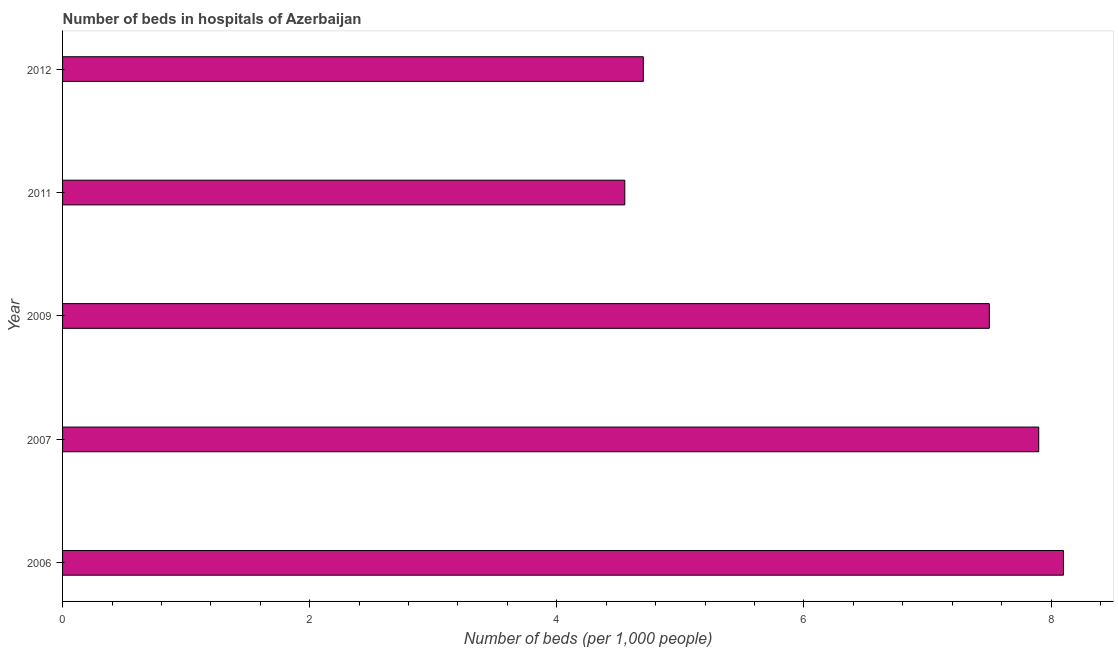Does the graph contain grids?
Give a very brief answer. No. What is the title of the graph?
Your answer should be very brief. Number of beds in hospitals of Azerbaijan. What is the label or title of the X-axis?
Provide a succinct answer. Number of beds (per 1,0 people). What is the label or title of the Y-axis?
Your answer should be compact. Year. What is the number of hospital beds in 2012?
Provide a short and direct response. 4.7. Across all years, what is the maximum number of hospital beds?
Your answer should be compact. 8.1. Across all years, what is the minimum number of hospital beds?
Keep it short and to the point. 4.55. In which year was the number of hospital beds maximum?
Make the answer very short. 2006. What is the sum of the number of hospital beds?
Keep it short and to the point. 32.75. What is the average number of hospital beds per year?
Ensure brevity in your answer.  6.55. What is the median number of hospital beds?
Provide a succinct answer. 7.5. In how many years, is the number of hospital beds greater than 3.6 %?
Ensure brevity in your answer.  5. What is the ratio of the number of hospital beds in 2007 to that in 2009?
Offer a very short reply. 1.05. Is the difference between the number of hospital beds in 2006 and 2009 greater than the difference between any two years?
Offer a very short reply. No. What is the difference between the highest and the second highest number of hospital beds?
Give a very brief answer. 0.2. What is the difference between the highest and the lowest number of hospital beds?
Make the answer very short. 3.55. In how many years, is the number of hospital beds greater than the average number of hospital beds taken over all years?
Ensure brevity in your answer.  3. Are all the bars in the graph horizontal?
Ensure brevity in your answer.  Yes. Are the values on the major ticks of X-axis written in scientific E-notation?
Keep it short and to the point. No. What is the Number of beds (per 1,000 people) of 2006?
Keep it short and to the point. 8.1. What is the Number of beds (per 1,000 people) of 2011?
Your response must be concise. 4.55. What is the difference between the Number of beds (per 1,000 people) in 2006 and 2011?
Give a very brief answer. 3.55. What is the difference between the Number of beds (per 1,000 people) in 2007 and 2011?
Your answer should be very brief. 3.35. What is the difference between the Number of beds (per 1,000 people) in 2009 and 2011?
Ensure brevity in your answer.  2.95. What is the difference between the Number of beds (per 1,000 people) in 2009 and 2012?
Ensure brevity in your answer.  2.8. What is the difference between the Number of beds (per 1,000 people) in 2011 and 2012?
Give a very brief answer. -0.15. What is the ratio of the Number of beds (per 1,000 people) in 2006 to that in 2011?
Keep it short and to the point. 1.78. What is the ratio of the Number of beds (per 1,000 people) in 2006 to that in 2012?
Provide a short and direct response. 1.72. What is the ratio of the Number of beds (per 1,000 people) in 2007 to that in 2009?
Your response must be concise. 1.05. What is the ratio of the Number of beds (per 1,000 people) in 2007 to that in 2011?
Offer a very short reply. 1.74. What is the ratio of the Number of beds (per 1,000 people) in 2007 to that in 2012?
Provide a succinct answer. 1.68. What is the ratio of the Number of beds (per 1,000 people) in 2009 to that in 2011?
Offer a very short reply. 1.65. What is the ratio of the Number of beds (per 1,000 people) in 2009 to that in 2012?
Make the answer very short. 1.6. What is the ratio of the Number of beds (per 1,000 people) in 2011 to that in 2012?
Offer a very short reply. 0.97. 